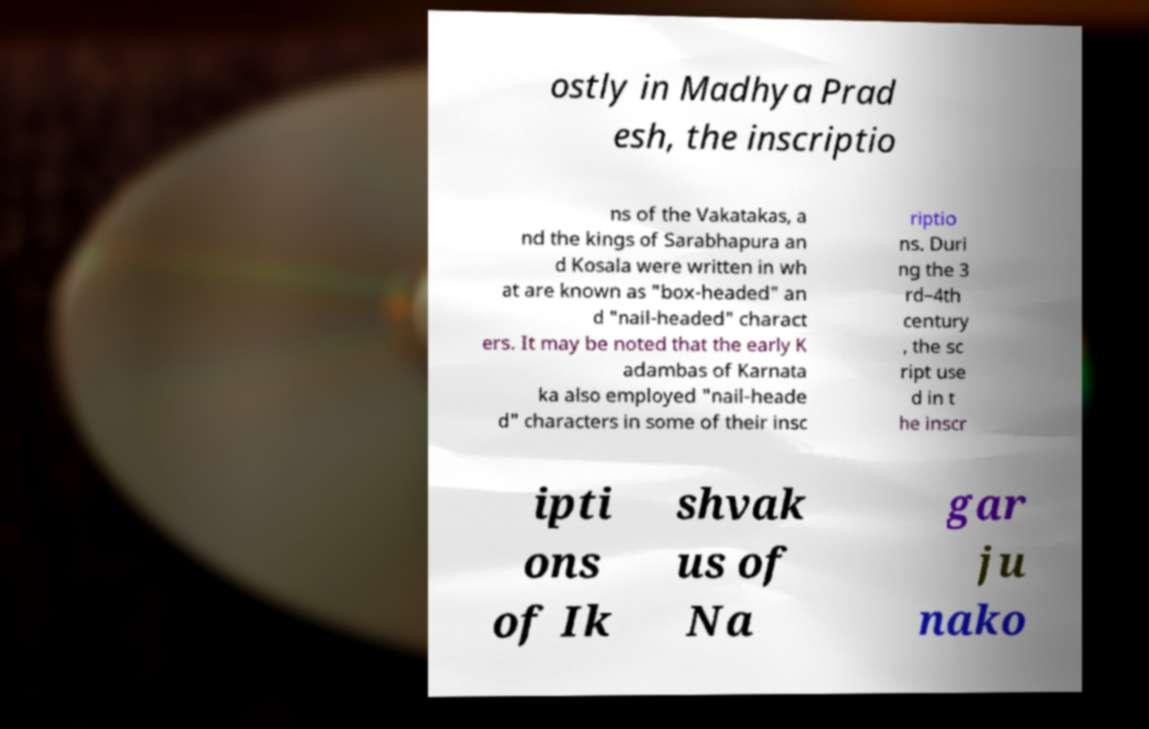Can you read and provide the text displayed in the image?This photo seems to have some interesting text. Can you extract and type it out for me? ostly in Madhya Prad esh, the inscriptio ns of the Vakatakas, a nd the kings of Sarabhapura an d Kosala were written in wh at are known as "box-headed" an d "nail-headed" charact ers. It may be noted that the early K adambas of Karnata ka also employed "nail-heade d" characters in some of their insc riptio ns. Duri ng the 3 rd–4th century , the sc ript use d in t he inscr ipti ons of Ik shvak us of Na gar ju nako 